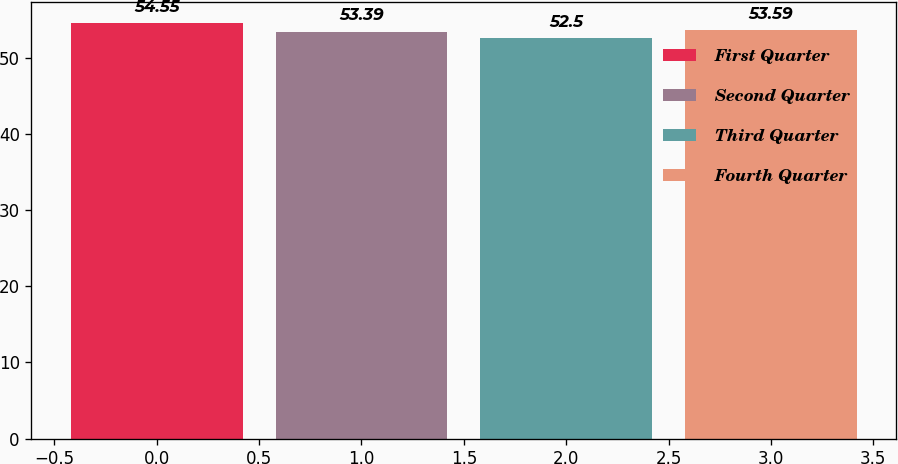Convert chart. <chart><loc_0><loc_0><loc_500><loc_500><bar_chart><fcel>First Quarter<fcel>Second Quarter<fcel>Third Quarter<fcel>Fourth Quarter<nl><fcel>54.55<fcel>53.39<fcel>52.5<fcel>53.59<nl></chart> 